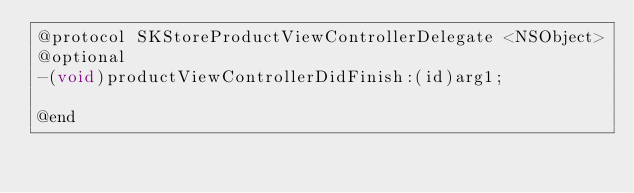<code> <loc_0><loc_0><loc_500><loc_500><_C_>@protocol SKStoreProductViewControllerDelegate <NSObject>
@optional
-(void)productViewControllerDidFinish:(id)arg1;

@end

</code> 